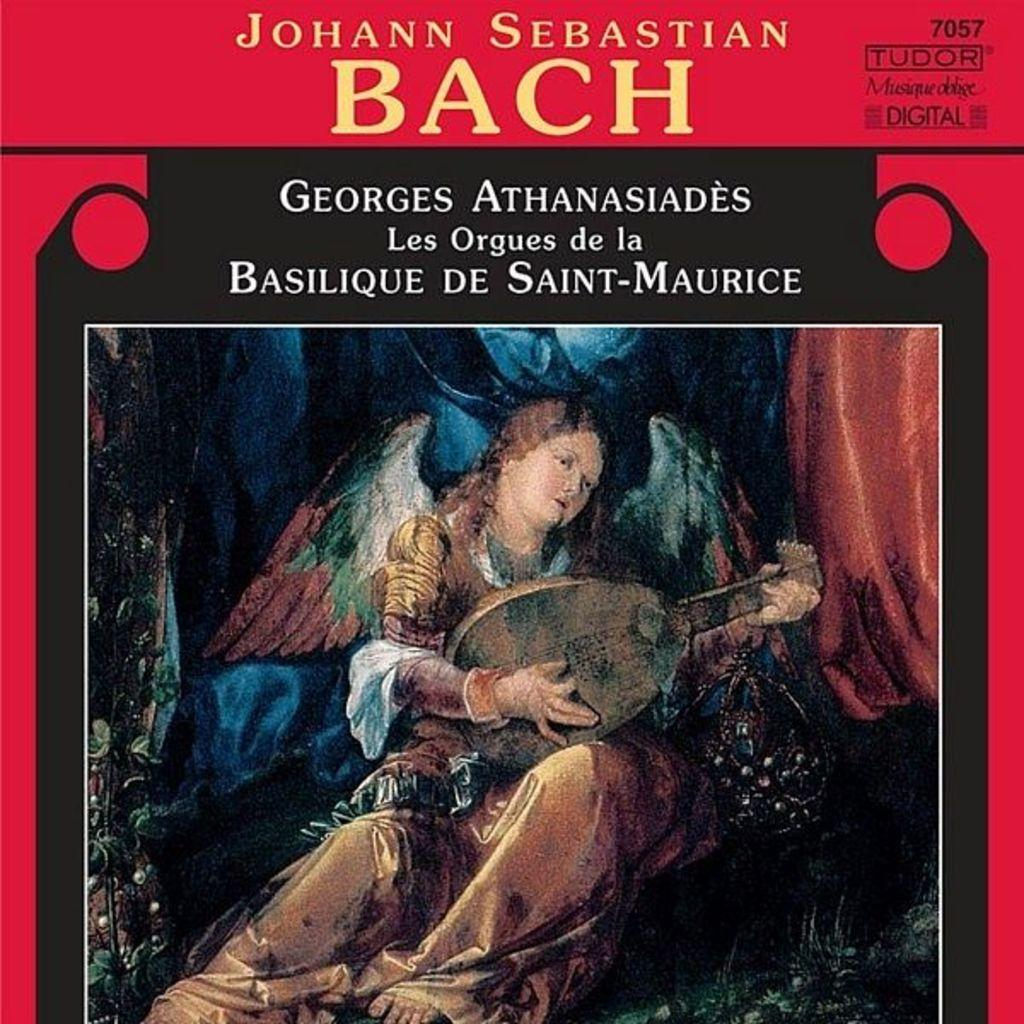<image>
Create a compact narrative representing the image presented. The album cover says Johann Sebastian Bach, Georges Athanasiades, Les Orgues de la Basilique de Saint-Maurice and features a renaissance type painting. 